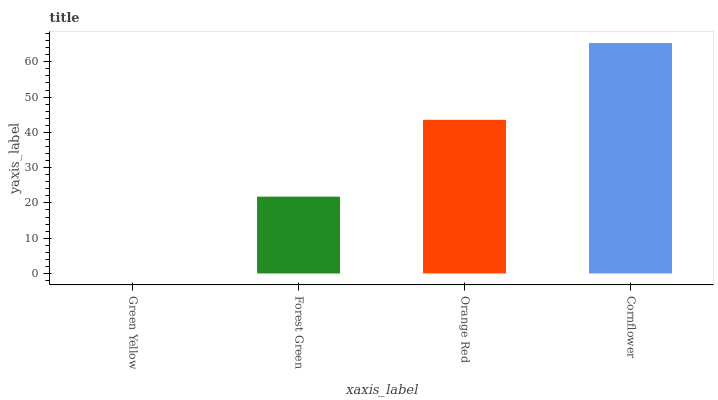Is Green Yellow the minimum?
Answer yes or no. Yes. Is Cornflower the maximum?
Answer yes or no. Yes. Is Forest Green the minimum?
Answer yes or no. No. Is Forest Green the maximum?
Answer yes or no. No. Is Forest Green greater than Green Yellow?
Answer yes or no. Yes. Is Green Yellow less than Forest Green?
Answer yes or no. Yes. Is Green Yellow greater than Forest Green?
Answer yes or no. No. Is Forest Green less than Green Yellow?
Answer yes or no. No. Is Orange Red the high median?
Answer yes or no. Yes. Is Forest Green the low median?
Answer yes or no. Yes. Is Cornflower the high median?
Answer yes or no. No. Is Cornflower the low median?
Answer yes or no. No. 